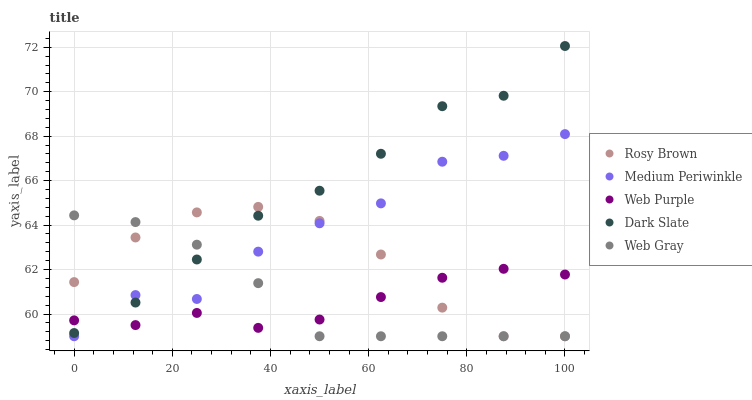Does Web Purple have the minimum area under the curve?
Answer yes or no. Yes. Does Dark Slate have the maximum area under the curve?
Answer yes or no. Yes. Does Dark Slate have the minimum area under the curve?
Answer yes or no. No. Does Web Purple have the maximum area under the curve?
Answer yes or no. No. Is Web Gray the smoothest?
Answer yes or no. Yes. Is Medium Periwinkle the roughest?
Answer yes or no. Yes. Is Dark Slate the smoothest?
Answer yes or no. No. Is Dark Slate the roughest?
Answer yes or no. No. Does Web Gray have the lowest value?
Answer yes or no. Yes. Does Dark Slate have the lowest value?
Answer yes or no. No. Does Dark Slate have the highest value?
Answer yes or no. Yes. Does Web Purple have the highest value?
Answer yes or no. No. Does Dark Slate intersect Web Gray?
Answer yes or no. Yes. Is Dark Slate less than Web Gray?
Answer yes or no. No. Is Dark Slate greater than Web Gray?
Answer yes or no. No. 